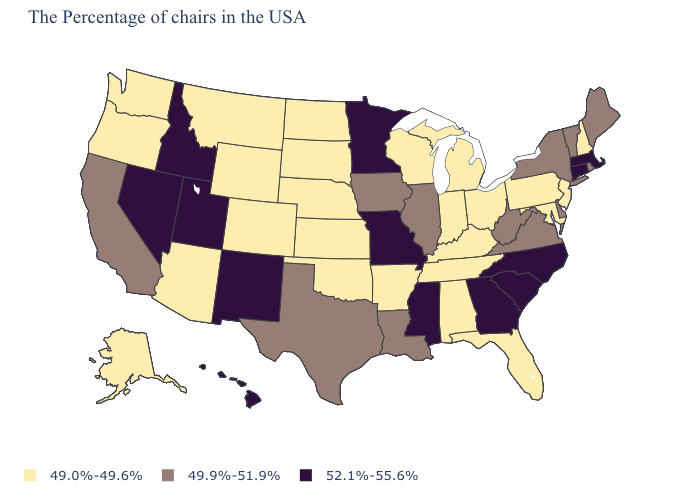What is the highest value in states that border New Hampshire?
Concise answer only. 52.1%-55.6%. What is the lowest value in states that border Vermont?
Concise answer only. 49.0%-49.6%. Among the states that border Missouri , does Illinois have the highest value?
Answer briefly. Yes. What is the value of New York?
Write a very short answer. 49.9%-51.9%. What is the value of Oklahoma?
Quick response, please. 49.0%-49.6%. What is the lowest value in states that border Minnesota?
Quick response, please. 49.0%-49.6%. Which states have the highest value in the USA?
Quick response, please. Massachusetts, Connecticut, North Carolina, South Carolina, Georgia, Mississippi, Missouri, Minnesota, New Mexico, Utah, Idaho, Nevada, Hawaii. How many symbols are there in the legend?
Short answer required. 3. What is the highest value in states that border South Dakota?
Short answer required. 52.1%-55.6%. Among the states that border Maryland , does Virginia have the lowest value?
Write a very short answer. No. Name the states that have a value in the range 52.1%-55.6%?
Give a very brief answer. Massachusetts, Connecticut, North Carolina, South Carolina, Georgia, Mississippi, Missouri, Minnesota, New Mexico, Utah, Idaho, Nevada, Hawaii. Which states have the lowest value in the USA?
Be succinct. New Hampshire, New Jersey, Maryland, Pennsylvania, Ohio, Florida, Michigan, Kentucky, Indiana, Alabama, Tennessee, Wisconsin, Arkansas, Kansas, Nebraska, Oklahoma, South Dakota, North Dakota, Wyoming, Colorado, Montana, Arizona, Washington, Oregon, Alaska. Does Texas have the same value as Vermont?
Quick response, please. Yes. Does Missouri have a higher value than Washington?
Answer briefly. Yes. Is the legend a continuous bar?
Quick response, please. No. 